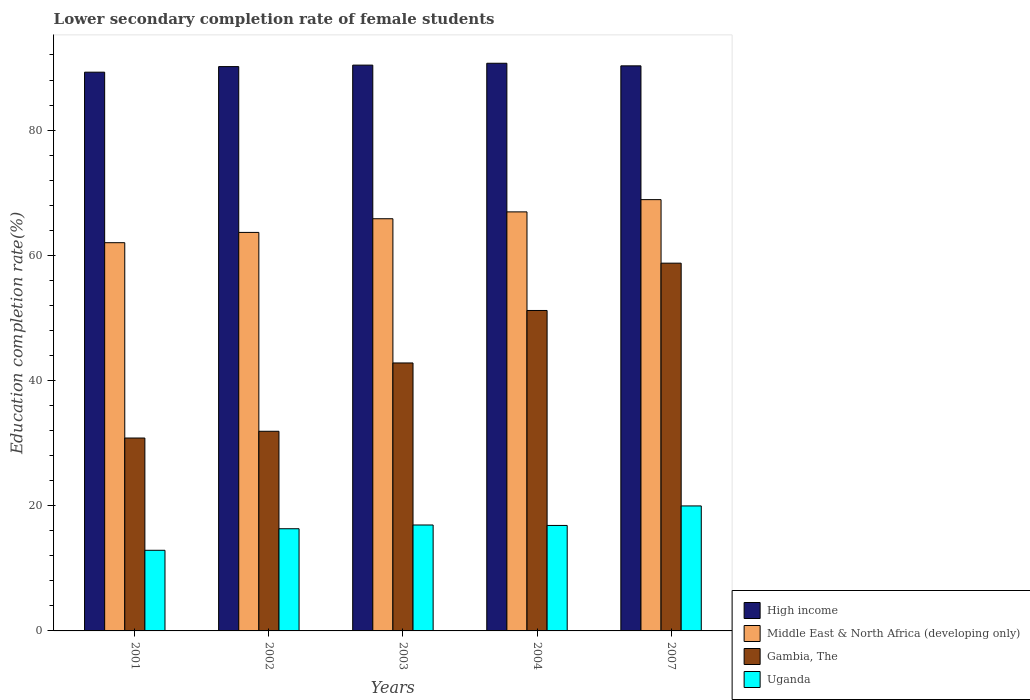Are the number of bars on each tick of the X-axis equal?
Your answer should be very brief. Yes. How many bars are there on the 2nd tick from the left?
Keep it short and to the point. 4. How many bars are there on the 3rd tick from the right?
Your response must be concise. 4. In how many cases, is the number of bars for a given year not equal to the number of legend labels?
Your answer should be very brief. 0. What is the lower secondary completion rate of female students in Middle East & North Africa (developing only) in 2004?
Offer a very short reply. 66.93. Across all years, what is the maximum lower secondary completion rate of female students in Gambia, The?
Provide a short and direct response. 58.74. Across all years, what is the minimum lower secondary completion rate of female students in High income?
Ensure brevity in your answer.  89.25. In which year was the lower secondary completion rate of female students in Uganda maximum?
Give a very brief answer. 2007. What is the total lower secondary completion rate of female students in Gambia, The in the graph?
Provide a succinct answer. 215.43. What is the difference between the lower secondary completion rate of female students in High income in 2003 and that in 2007?
Provide a succinct answer. 0.12. What is the difference between the lower secondary completion rate of female students in Middle East & North Africa (developing only) in 2003 and the lower secondary completion rate of female students in Gambia, The in 2002?
Your answer should be very brief. 33.95. What is the average lower secondary completion rate of female students in High income per year?
Provide a succinct answer. 90.14. In the year 2002, what is the difference between the lower secondary completion rate of female students in Uganda and lower secondary completion rate of female students in Middle East & North Africa (developing only)?
Offer a terse response. -47.34. What is the ratio of the lower secondary completion rate of female students in Uganda in 2002 to that in 2003?
Your answer should be compact. 0.96. Is the lower secondary completion rate of female students in Middle East & North Africa (developing only) in 2004 less than that in 2007?
Your response must be concise. Yes. What is the difference between the highest and the second highest lower secondary completion rate of female students in Gambia, The?
Your answer should be compact. 7.56. What is the difference between the highest and the lowest lower secondary completion rate of female students in Uganda?
Give a very brief answer. 7.08. In how many years, is the lower secondary completion rate of female students in Uganda greater than the average lower secondary completion rate of female students in Uganda taken over all years?
Make the answer very short. 3. Is the sum of the lower secondary completion rate of female students in Uganda in 2001 and 2003 greater than the maximum lower secondary completion rate of female students in Middle East & North Africa (developing only) across all years?
Offer a very short reply. No. What does the 4th bar from the left in 2004 represents?
Make the answer very short. Uganda. What does the 1st bar from the right in 2002 represents?
Provide a short and direct response. Uganda. How many bars are there?
Provide a short and direct response. 20. How many years are there in the graph?
Give a very brief answer. 5. What is the difference between two consecutive major ticks on the Y-axis?
Your answer should be very brief. 20. Are the values on the major ticks of Y-axis written in scientific E-notation?
Your answer should be compact. No. Does the graph contain grids?
Your answer should be very brief. No. Where does the legend appear in the graph?
Ensure brevity in your answer.  Bottom right. How many legend labels are there?
Your answer should be very brief. 4. How are the legend labels stacked?
Ensure brevity in your answer.  Vertical. What is the title of the graph?
Ensure brevity in your answer.  Lower secondary completion rate of female students. Does "St. Lucia" appear as one of the legend labels in the graph?
Make the answer very short. No. What is the label or title of the Y-axis?
Offer a very short reply. Education completion rate(%). What is the Education completion rate(%) in High income in 2001?
Provide a succinct answer. 89.25. What is the Education completion rate(%) in Middle East & North Africa (developing only) in 2001?
Make the answer very short. 62.01. What is the Education completion rate(%) in Gambia, The in 2001?
Your response must be concise. 30.81. What is the Education completion rate(%) in Uganda in 2001?
Offer a terse response. 12.88. What is the Education completion rate(%) of High income in 2002?
Keep it short and to the point. 90.14. What is the Education completion rate(%) in Middle East & North Africa (developing only) in 2002?
Offer a terse response. 63.66. What is the Education completion rate(%) in Gambia, The in 2002?
Give a very brief answer. 31.89. What is the Education completion rate(%) of Uganda in 2002?
Ensure brevity in your answer.  16.32. What is the Education completion rate(%) in High income in 2003?
Make the answer very short. 90.38. What is the Education completion rate(%) of Middle East & North Africa (developing only) in 2003?
Offer a terse response. 65.84. What is the Education completion rate(%) of Gambia, The in 2003?
Ensure brevity in your answer.  42.8. What is the Education completion rate(%) of Uganda in 2003?
Your response must be concise. 16.92. What is the Education completion rate(%) of High income in 2004?
Your answer should be very brief. 90.67. What is the Education completion rate(%) in Middle East & North Africa (developing only) in 2004?
Offer a very short reply. 66.93. What is the Education completion rate(%) of Gambia, The in 2004?
Provide a succinct answer. 51.18. What is the Education completion rate(%) of Uganda in 2004?
Offer a very short reply. 16.85. What is the Education completion rate(%) of High income in 2007?
Keep it short and to the point. 90.26. What is the Education completion rate(%) of Middle East & North Africa (developing only) in 2007?
Your answer should be compact. 68.89. What is the Education completion rate(%) of Gambia, The in 2007?
Give a very brief answer. 58.74. What is the Education completion rate(%) of Uganda in 2007?
Give a very brief answer. 19.97. Across all years, what is the maximum Education completion rate(%) in High income?
Provide a short and direct response. 90.67. Across all years, what is the maximum Education completion rate(%) in Middle East & North Africa (developing only)?
Offer a very short reply. 68.89. Across all years, what is the maximum Education completion rate(%) in Gambia, The?
Offer a very short reply. 58.74. Across all years, what is the maximum Education completion rate(%) of Uganda?
Your answer should be very brief. 19.97. Across all years, what is the minimum Education completion rate(%) in High income?
Offer a terse response. 89.25. Across all years, what is the minimum Education completion rate(%) in Middle East & North Africa (developing only)?
Offer a terse response. 62.01. Across all years, what is the minimum Education completion rate(%) in Gambia, The?
Offer a terse response. 30.81. Across all years, what is the minimum Education completion rate(%) of Uganda?
Give a very brief answer. 12.88. What is the total Education completion rate(%) in High income in the graph?
Offer a terse response. 450.7. What is the total Education completion rate(%) of Middle East & North Africa (developing only) in the graph?
Provide a succinct answer. 327.33. What is the total Education completion rate(%) of Gambia, The in the graph?
Make the answer very short. 215.43. What is the total Education completion rate(%) in Uganda in the graph?
Offer a very short reply. 82.93. What is the difference between the Education completion rate(%) of High income in 2001 and that in 2002?
Give a very brief answer. -0.89. What is the difference between the Education completion rate(%) in Middle East & North Africa (developing only) in 2001 and that in 2002?
Offer a terse response. -1.64. What is the difference between the Education completion rate(%) in Gambia, The in 2001 and that in 2002?
Your answer should be compact. -1.08. What is the difference between the Education completion rate(%) in Uganda in 2001 and that in 2002?
Your response must be concise. -3.44. What is the difference between the Education completion rate(%) of High income in 2001 and that in 2003?
Offer a terse response. -1.13. What is the difference between the Education completion rate(%) in Middle East & North Africa (developing only) in 2001 and that in 2003?
Ensure brevity in your answer.  -3.83. What is the difference between the Education completion rate(%) of Gambia, The in 2001 and that in 2003?
Make the answer very short. -11.99. What is the difference between the Education completion rate(%) of Uganda in 2001 and that in 2003?
Give a very brief answer. -4.04. What is the difference between the Education completion rate(%) of High income in 2001 and that in 2004?
Give a very brief answer. -1.43. What is the difference between the Education completion rate(%) of Middle East & North Africa (developing only) in 2001 and that in 2004?
Your answer should be very brief. -4.92. What is the difference between the Education completion rate(%) in Gambia, The in 2001 and that in 2004?
Make the answer very short. -20.37. What is the difference between the Education completion rate(%) in Uganda in 2001 and that in 2004?
Offer a terse response. -3.97. What is the difference between the Education completion rate(%) of High income in 2001 and that in 2007?
Your answer should be very brief. -1.01. What is the difference between the Education completion rate(%) of Middle East & North Africa (developing only) in 2001 and that in 2007?
Ensure brevity in your answer.  -6.88. What is the difference between the Education completion rate(%) in Gambia, The in 2001 and that in 2007?
Provide a short and direct response. -27.93. What is the difference between the Education completion rate(%) in Uganda in 2001 and that in 2007?
Your response must be concise. -7.08. What is the difference between the Education completion rate(%) of High income in 2002 and that in 2003?
Provide a succinct answer. -0.24. What is the difference between the Education completion rate(%) in Middle East & North Africa (developing only) in 2002 and that in 2003?
Provide a short and direct response. -2.18. What is the difference between the Education completion rate(%) of Gambia, The in 2002 and that in 2003?
Your response must be concise. -10.91. What is the difference between the Education completion rate(%) in Uganda in 2002 and that in 2003?
Provide a succinct answer. -0.6. What is the difference between the Education completion rate(%) in High income in 2002 and that in 2004?
Give a very brief answer. -0.53. What is the difference between the Education completion rate(%) of Middle East & North Africa (developing only) in 2002 and that in 2004?
Your response must be concise. -3.28. What is the difference between the Education completion rate(%) in Gambia, The in 2002 and that in 2004?
Provide a succinct answer. -19.29. What is the difference between the Education completion rate(%) of Uganda in 2002 and that in 2004?
Give a very brief answer. -0.53. What is the difference between the Education completion rate(%) of High income in 2002 and that in 2007?
Give a very brief answer. -0.12. What is the difference between the Education completion rate(%) in Middle East & North Africa (developing only) in 2002 and that in 2007?
Your response must be concise. -5.24. What is the difference between the Education completion rate(%) of Gambia, The in 2002 and that in 2007?
Offer a very short reply. -26.85. What is the difference between the Education completion rate(%) of Uganda in 2002 and that in 2007?
Give a very brief answer. -3.64. What is the difference between the Education completion rate(%) in High income in 2003 and that in 2004?
Provide a short and direct response. -0.3. What is the difference between the Education completion rate(%) of Middle East & North Africa (developing only) in 2003 and that in 2004?
Your answer should be very brief. -1.1. What is the difference between the Education completion rate(%) in Gambia, The in 2003 and that in 2004?
Provide a succinct answer. -8.38. What is the difference between the Education completion rate(%) in Uganda in 2003 and that in 2004?
Keep it short and to the point. 0.07. What is the difference between the Education completion rate(%) in High income in 2003 and that in 2007?
Your answer should be very brief. 0.12. What is the difference between the Education completion rate(%) in Middle East & North Africa (developing only) in 2003 and that in 2007?
Offer a very short reply. -3.05. What is the difference between the Education completion rate(%) of Gambia, The in 2003 and that in 2007?
Keep it short and to the point. -15.94. What is the difference between the Education completion rate(%) of Uganda in 2003 and that in 2007?
Your answer should be compact. -3.04. What is the difference between the Education completion rate(%) of High income in 2004 and that in 2007?
Your answer should be very brief. 0.41. What is the difference between the Education completion rate(%) of Middle East & North Africa (developing only) in 2004 and that in 2007?
Your answer should be compact. -1.96. What is the difference between the Education completion rate(%) of Gambia, The in 2004 and that in 2007?
Your answer should be very brief. -7.56. What is the difference between the Education completion rate(%) in Uganda in 2004 and that in 2007?
Provide a short and direct response. -3.12. What is the difference between the Education completion rate(%) in High income in 2001 and the Education completion rate(%) in Middle East & North Africa (developing only) in 2002?
Provide a succinct answer. 25.59. What is the difference between the Education completion rate(%) of High income in 2001 and the Education completion rate(%) of Gambia, The in 2002?
Offer a very short reply. 57.36. What is the difference between the Education completion rate(%) of High income in 2001 and the Education completion rate(%) of Uganda in 2002?
Your response must be concise. 72.93. What is the difference between the Education completion rate(%) of Middle East & North Africa (developing only) in 2001 and the Education completion rate(%) of Gambia, The in 2002?
Offer a very short reply. 30.12. What is the difference between the Education completion rate(%) in Middle East & North Africa (developing only) in 2001 and the Education completion rate(%) in Uganda in 2002?
Give a very brief answer. 45.69. What is the difference between the Education completion rate(%) in Gambia, The in 2001 and the Education completion rate(%) in Uganda in 2002?
Keep it short and to the point. 14.49. What is the difference between the Education completion rate(%) in High income in 2001 and the Education completion rate(%) in Middle East & North Africa (developing only) in 2003?
Provide a succinct answer. 23.41. What is the difference between the Education completion rate(%) of High income in 2001 and the Education completion rate(%) of Gambia, The in 2003?
Your answer should be compact. 46.45. What is the difference between the Education completion rate(%) of High income in 2001 and the Education completion rate(%) of Uganda in 2003?
Provide a succinct answer. 72.33. What is the difference between the Education completion rate(%) in Middle East & North Africa (developing only) in 2001 and the Education completion rate(%) in Gambia, The in 2003?
Keep it short and to the point. 19.21. What is the difference between the Education completion rate(%) of Middle East & North Africa (developing only) in 2001 and the Education completion rate(%) of Uganda in 2003?
Offer a terse response. 45.09. What is the difference between the Education completion rate(%) in Gambia, The in 2001 and the Education completion rate(%) in Uganda in 2003?
Provide a short and direct response. 13.89. What is the difference between the Education completion rate(%) in High income in 2001 and the Education completion rate(%) in Middle East & North Africa (developing only) in 2004?
Ensure brevity in your answer.  22.31. What is the difference between the Education completion rate(%) in High income in 2001 and the Education completion rate(%) in Gambia, The in 2004?
Your answer should be compact. 38.06. What is the difference between the Education completion rate(%) of High income in 2001 and the Education completion rate(%) of Uganda in 2004?
Give a very brief answer. 72.4. What is the difference between the Education completion rate(%) of Middle East & North Africa (developing only) in 2001 and the Education completion rate(%) of Gambia, The in 2004?
Offer a terse response. 10.83. What is the difference between the Education completion rate(%) in Middle East & North Africa (developing only) in 2001 and the Education completion rate(%) in Uganda in 2004?
Make the answer very short. 45.16. What is the difference between the Education completion rate(%) of Gambia, The in 2001 and the Education completion rate(%) of Uganda in 2004?
Your response must be concise. 13.96. What is the difference between the Education completion rate(%) in High income in 2001 and the Education completion rate(%) in Middle East & North Africa (developing only) in 2007?
Provide a short and direct response. 20.36. What is the difference between the Education completion rate(%) of High income in 2001 and the Education completion rate(%) of Gambia, The in 2007?
Ensure brevity in your answer.  30.51. What is the difference between the Education completion rate(%) in High income in 2001 and the Education completion rate(%) in Uganda in 2007?
Give a very brief answer. 69.28. What is the difference between the Education completion rate(%) of Middle East & North Africa (developing only) in 2001 and the Education completion rate(%) of Gambia, The in 2007?
Ensure brevity in your answer.  3.27. What is the difference between the Education completion rate(%) of Middle East & North Africa (developing only) in 2001 and the Education completion rate(%) of Uganda in 2007?
Ensure brevity in your answer.  42.05. What is the difference between the Education completion rate(%) in Gambia, The in 2001 and the Education completion rate(%) in Uganda in 2007?
Keep it short and to the point. 10.85. What is the difference between the Education completion rate(%) in High income in 2002 and the Education completion rate(%) in Middle East & North Africa (developing only) in 2003?
Give a very brief answer. 24.3. What is the difference between the Education completion rate(%) in High income in 2002 and the Education completion rate(%) in Gambia, The in 2003?
Offer a very short reply. 47.34. What is the difference between the Education completion rate(%) of High income in 2002 and the Education completion rate(%) of Uganda in 2003?
Make the answer very short. 73.22. What is the difference between the Education completion rate(%) in Middle East & North Africa (developing only) in 2002 and the Education completion rate(%) in Gambia, The in 2003?
Give a very brief answer. 20.85. What is the difference between the Education completion rate(%) of Middle East & North Africa (developing only) in 2002 and the Education completion rate(%) of Uganda in 2003?
Make the answer very short. 46.74. What is the difference between the Education completion rate(%) in Gambia, The in 2002 and the Education completion rate(%) in Uganda in 2003?
Give a very brief answer. 14.97. What is the difference between the Education completion rate(%) in High income in 2002 and the Education completion rate(%) in Middle East & North Africa (developing only) in 2004?
Provide a short and direct response. 23.21. What is the difference between the Education completion rate(%) in High income in 2002 and the Education completion rate(%) in Gambia, The in 2004?
Ensure brevity in your answer.  38.96. What is the difference between the Education completion rate(%) of High income in 2002 and the Education completion rate(%) of Uganda in 2004?
Make the answer very short. 73.29. What is the difference between the Education completion rate(%) of Middle East & North Africa (developing only) in 2002 and the Education completion rate(%) of Gambia, The in 2004?
Your answer should be compact. 12.47. What is the difference between the Education completion rate(%) in Middle East & North Africa (developing only) in 2002 and the Education completion rate(%) in Uganda in 2004?
Keep it short and to the point. 46.81. What is the difference between the Education completion rate(%) of Gambia, The in 2002 and the Education completion rate(%) of Uganda in 2004?
Offer a terse response. 15.04. What is the difference between the Education completion rate(%) in High income in 2002 and the Education completion rate(%) in Middle East & North Africa (developing only) in 2007?
Your response must be concise. 21.25. What is the difference between the Education completion rate(%) of High income in 2002 and the Education completion rate(%) of Gambia, The in 2007?
Your answer should be very brief. 31.4. What is the difference between the Education completion rate(%) of High income in 2002 and the Education completion rate(%) of Uganda in 2007?
Make the answer very short. 70.18. What is the difference between the Education completion rate(%) in Middle East & North Africa (developing only) in 2002 and the Education completion rate(%) in Gambia, The in 2007?
Offer a terse response. 4.91. What is the difference between the Education completion rate(%) of Middle East & North Africa (developing only) in 2002 and the Education completion rate(%) of Uganda in 2007?
Provide a succinct answer. 43.69. What is the difference between the Education completion rate(%) of Gambia, The in 2002 and the Education completion rate(%) of Uganda in 2007?
Give a very brief answer. 11.93. What is the difference between the Education completion rate(%) in High income in 2003 and the Education completion rate(%) in Middle East & North Africa (developing only) in 2004?
Provide a succinct answer. 23.44. What is the difference between the Education completion rate(%) of High income in 2003 and the Education completion rate(%) of Gambia, The in 2004?
Make the answer very short. 39.19. What is the difference between the Education completion rate(%) in High income in 2003 and the Education completion rate(%) in Uganda in 2004?
Keep it short and to the point. 73.53. What is the difference between the Education completion rate(%) of Middle East & North Africa (developing only) in 2003 and the Education completion rate(%) of Gambia, The in 2004?
Make the answer very short. 14.65. What is the difference between the Education completion rate(%) of Middle East & North Africa (developing only) in 2003 and the Education completion rate(%) of Uganda in 2004?
Your response must be concise. 48.99. What is the difference between the Education completion rate(%) in Gambia, The in 2003 and the Education completion rate(%) in Uganda in 2004?
Make the answer very short. 25.96. What is the difference between the Education completion rate(%) of High income in 2003 and the Education completion rate(%) of Middle East & North Africa (developing only) in 2007?
Give a very brief answer. 21.49. What is the difference between the Education completion rate(%) of High income in 2003 and the Education completion rate(%) of Gambia, The in 2007?
Make the answer very short. 31.63. What is the difference between the Education completion rate(%) of High income in 2003 and the Education completion rate(%) of Uganda in 2007?
Make the answer very short. 70.41. What is the difference between the Education completion rate(%) of Middle East & North Africa (developing only) in 2003 and the Education completion rate(%) of Gambia, The in 2007?
Ensure brevity in your answer.  7.09. What is the difference between the Education completion rate(%) in Middle East & North Africa (developing only) in 2003 and the Education completion rate(%) in Uganda in 2007?
Your answer should be compact. 45.87. What is the difference between the Education completion rate(%) in Gambia, The in 2003 and the Education completion rate(%) in Uganda in 2007?
Offer a terse response. 22.84. What is the difference between the Education completion rate(%) in High income in 2004 and the Education completion rate(%) in Middle East & North Africa (developing only) in 2007?
Keep it short and to the point. 21.78. What is the difference between the Education completion rate(%) of High income in 2004 and the Education completion rate(%) of Gambia, The in 2007?
Give a very brief answer. 31.93. What is the difference between the Education completion rate(%) of High income in 2004 and the Education completion rate(%) of Uganda in 2007?
Make the answer very short. 70.71. What is the difference between the Education completion rate(%) of Middle East & North Africa (developing only) in 2004 and the Education completion rate(%) of Gambia, The in 2007?
Your response must be concise. 8.19. What is the difference between the Education completion rate(%) in Middle East & North Africa (developing only) in 2004 and the Education completion rate(%) in Uganda in 2007?
Keep it short and to the point. 46.97. What is the difference between the Education completion rate(%) in Gambia, The in 2004 and the Education completion rate(%) in Uganda in 2007?
Keep it short and to the point. 31.22. What is the average Education completion rate(%) in High income per year?
Your answer should be compact. 90.14. What is the average Education completion rate(%) of Middle East & North Africa (developing only) per year?
Your answer should be compact. 65.47. What is the average Education completion rate(%) in Gambia, The per year?
Your answer should be very brief. 43.09. What is the average Education completion rate(%) in Uganda per year?
Keep it short and to the point. 16.59. In the year 2001, what is the difference between the Education completion rate(%) of High income and Education completion rate(%) of Middle East & North Africa (developing only)?
Your response must be concise. 27.24. In the year 2001, what is the difference between the Education completion rate(%) of High income and Education completion rate(%) of Gambia, The?
Keep it short and to the point. 58.44. In the year 2001, what is the difference between the Education completion rate(%) in High income and Education completion rate(%) in Uganda?
Offer a very short reply. 76.37. In the year 2001, what is the difference between the Education completion rate(%) of Middle East & North Africa (developing only) and Education completion rate(%) of Gambia, The?
Your response must be concise. 31.2. In the year 2001, what is the difference between the Education completion rate(%) in Middle East & North Africa (developing only) and Education completion rate(%) in Uganda?
Make the answer very short. 49.13. In the year 2001, what is the difference between the Education completion rate(%) in Gambia, The and Education completion rate(%) in Uganda?
Offer a terse response. 17.93. In the year 2002, what is the difference between the Education completion rate(%) in High income and Education completion rate(%) in Middle East & North Africa (developing only)?
Make the answer very short. 26.49. In the year 2002, what is the difference between the Education completion rate(%) of High income and Education completion rate(%) of Gambia, The?
Offer a terse response. 58.25. In the year 2002, what is the difference between the Education completion rate(%) of High income and Education completion rate(%) of Uganda?
Your answer should be compact. 73.82. In the year 2002, what is the difference between the Education completion rate(%) of Middle East & North Africa (developing only) and Education completion rate(%) of Gambia, The?
Your response must be concise. 31.76. In the year 2002, what is the difference between the Education completion rate(%) in Middle East & North Africa (developing only) and Education completion rate(%) in Uganda?
Keep it short and to the point. 47.34. In the year 2002, what is the difference between the Education completion rate(%) of Gambia, The and Education completion rate(%) of Uganda?
Your answer should be very brief. 15.57. In the year 2003, what is the difference between the Education completion rate(%) of High income and Education completion rate(%) of Middle East & North Africa (developing only)?
Provide a succinct answer. 24.54. In the year 2003, what is the difference between the Education completion rate(%) in High income and Education completion rate(%) in Gambia, The?
Ensure brevity in your answer.  47.57. In the year 2003, what is the difference between the Education completion rate(%) in High income and Education completion rate(%) in Uganda?
Make the answer very short. 73.46. In the year 2003, what is the difference between the Education completion rate(%) of Middle East & North Africa (developing only) and Education completion rate(%) of Gambia, The?
Provide a short and direct response. 23.04. In the year 2003, what is the difference between the Education completion rate(%) of Middle East & North Africa (developing only) and Education completion rate(%) of Uganda?
Offer a terse response. 48.92. In the year 2003, what is the difference between the Education completion rate(%) in Gambia, The and Education completion rate(%) in Uganda?
Provide a succinct answer. 25.88. In the year 2004, what is the difference between the Education completion rate(%) of High income and Education completion rate(%) of Middle East & North Africa (developing only)?
Provide a succinct answer. 23.74. In the year 2004, what is the difference between the Education completion rate(%) of High income and Education completion rate(%) of Gambia, The?
Provide a succinct answer. 39.49. In the year 2004, what is the difference between the Education completion rate(%) of High income and Education completion rate(%) of Uganda?
Keep it short and to the point. 73.83. In the year 2004, what is the difference between the Education completion rate(%) of Middle East & North Africa (developing only) and Education completion rate(%) of Gambia, The?
Make the answer very short. 15.75. In the year 2004, what is the difference between the Education completion rate(%) in Middle East & North Africa (developing only) and Education completion rate(%) in Uganda?
Your answer should be compact. 50.09. In the year 2004, what is the difference between the Education completion rate(%) in Gambia, The and Education completion rate(%) in Uganda?
Offer a terse response. 34.34. In the year 2007, what is the difference between the Education completion rate(%) of High income and Education completion rate(%) of Middle East & North Africa (developing only)?
Offer a very short reply. 21.37. In the year 2007, what is the difference between the Education completion rate(%) in High income and Education completion rate(%) in Gambia, The?
Provide a succinct answer. 31.52. In the year 2007, what is the difference between the Education completion rate(%) of High income and Education completion rate(%) of Uganda?
Provide a succinct answer. 70.3. In the year 2007, what is the difference between the Education completion rate(%) of Middle East & North Africa (developing only) and Education completion rate(%) of Gambia, The?
Offer a very short reply. 10.15. In the year 2007, what is the difference between the Education completion rate(%) of Middle East & North Africa (developing only) and Education completion rate(%) of Uganda?
Keep it short and to the point. 48.93. In the year 2007, what is the difference between the Education completion rate(%) in Gambia, The and Education completion rate(%) in Uganda?
Provide a succinct answer. 38.78. What is the ratio of the Education completion rate(%) of High income in 2001 to that in 2002?
Provide a short and direct response. 0.99. What is the ratio of the Education completion rate(%) in Middle East & North Africa (developing only) in 2001 to that in 2002?
Provide a succinct answer. 0.97. What is the ratio of the Education completion rate(%) in Gambia, The in 2001 to that in 2002?
Offer a terse response. 0.97. What is the ratio of the Education completion rate(%) of Uganda in 2001 to that in 2002?
Give a very brief answer. 0.79. What is the ratio of the Education completion rate(%) of High income in 2001 to that in 2003?
Keep it short and to the point. 0.99. What is the ratio of the Education completion rate(%) of Middle East & North Africa (developing only) in 2001 to that in 2003?
Give a very brief answer. 0.94. What is the ratio of the Education completion rate(%) in Gambia, The in 2001 to that in 2003?
Your answer should be compact. 0.72. What is the ratio of the Education completion rate(%) in Uganda in 2001 to that in 2003?
Your answer should be compact. 0.76. What is the ratio of the Education completion rate(%) of High income in 2001 to that in 2004?
Keep it short and to the point. 0.98. What is the ratio of the Education completion rate(%) in Middle East & North Africa (developing only) in 2001 to that in 2004?
Provide a succinct answer. 0.93. What is the ratio of the Education completion rate(%) in Gambia, The in 2001 to that in 2004?
Give a very brief answer. 0.6. What is the ratio of the Education completion rate(%) in Uganda in 2001 to that in 2004?
Keep it short and to the point. 0.76. What is the ratio of the Education completion rate(%) of Middle East & North Africa (developing only) in 2001 to that in 2007?
Your answer should be very brief. 0.9. What is the ratio of the Education completion rate(%) of Gambia, The in 2001 to that in 2007?
Your response must be concise. 0.52. What is the ratio of the Education completion rate(%) of Uganda in 2001 to that in 2007?
Your response must be concise. 0.65. What is the ratio of the Education completion rate(%) in Middle East & North Africa (developing only) in 2002 to that in 2003?
Your answer should be compact. 0.97. What is the ratio of the Education completion rate(%) of Gambia, The in 2002 to that in 2003?
Provide a succinct answer. 0.75. What is the ratio of the Education completion rate(%) of Uganda in 2002 to that in 2003?
Keep it short and to the point. 0.96. What is the ratio of the Education completion rate(%) in High income in 2002 to that in 2004?
Your answer should be very brief. 0.99. What is the ratio of the Education completion rate(%) of Middle East & North Africa (developing only) in 2002 to that in 2004?
Offer a very short reply. 0.95. What is the ratio of the Education completion rate(%) in Gambia, The in 2002 to that in 2004?
Your answer should be very brief. 0.62. What is the ratio of the Education completion rate(%) in Uganda in 2002 to that in 2004?
Ensure brevity in your answer.  0.97. What is the ratio of the Education completion rate(%) of Middle East & North Africa (developing only) in 2002 to that in 2007?
Keep it short and to the point. 0.92. What is the ratio of the Education completion rate(%) in Gambia, The in 2002 to that in 2007?
Give a very brief answer. 0.54. What is the ratio of the Education completion rate(%) in Uganda in 2002 to that in 2007?
Give a very brief answer. 0.82. What is the ratio of the Education completion rate(%) of Middle East & North Africa (developing only) in 2003 to that in 2004?
Offer a terse response. 0.98. What is the ratio of the Education completion rate(%) in Gambia, The in 2003 to that in 2004?
Offer a very short reply. 0.84. What is the ratio of the Education completion rate(%) of Uganda in 2003 to that in 2004?
Your answer should be compact. 1. What is the ratio of the Education completion rate(%) in High income in 2003 to that in 2007?
Keep it short and to the point. 1. What is the ratio of the Education completion rate(%) in Middle East & North Africa (developing only) in 2003 to that in 2007?
Make the answer very short. 0.96. What is the ratio of the Education completion rate(%) of Gambia, The in 2003 to that in 2007?
Your response must be concise. 0.73. What is the ratio of the Education completion rate(%) in Uganda in 2003 to that in 2007?
Offer a very short reply. 0.85. What is the ratio of the Education completion rate(%) in High income in 2004 to that in 2007?
Your answer should be compact. 1. What is the ratio of the Education completion rate(%) in Middle East & North Africa (developing only) in 2004 to that in 2007?
Your answer should be very brief. 0.97. What is the ratio of the Education completion rate(%) of Gambia, The in 2004 to that in 2007?
Keep it short and to the point. 0.87. What is the ratio of the Education completion rate(%) of Uganda in 2004 to that in 2007?
Your response must be concise. 0.84. What is the difference between the highest and the second highest Education completion rate(%) in High income?
Keep it short and to the point. 0.3. What is the difference between the highest and the second highest Education completion rate(%) of Middle East & North Africa (developing only)?
Offer a very short reply. 1.96. What is the difference between the highest and the second highest Education completion rate(%) of Gambia, The?
Your answer should be compact. 7.56. What is the difference between the highest and the second highest Education completion rate(%) in Uganda?
Provide a succinct answer. 3.04. What is the difference between the highest and the lowest Education completion rate(%) of High income?
Make the answer very short. 1.43. What is the difference between the highest and the lowest Education completion rate(%) in Middle East & North Africa (developing only)?
Provide a succinct answer. 6.88. What is the difference between the highest and the lowest Education completion rate(%) of Gambia, The?
Ensure brevity in your answer.  27.93. What is the difference between the highest and the lowest Education completion rate(%) of Uganda?
Your response must be concise. 7.08. 